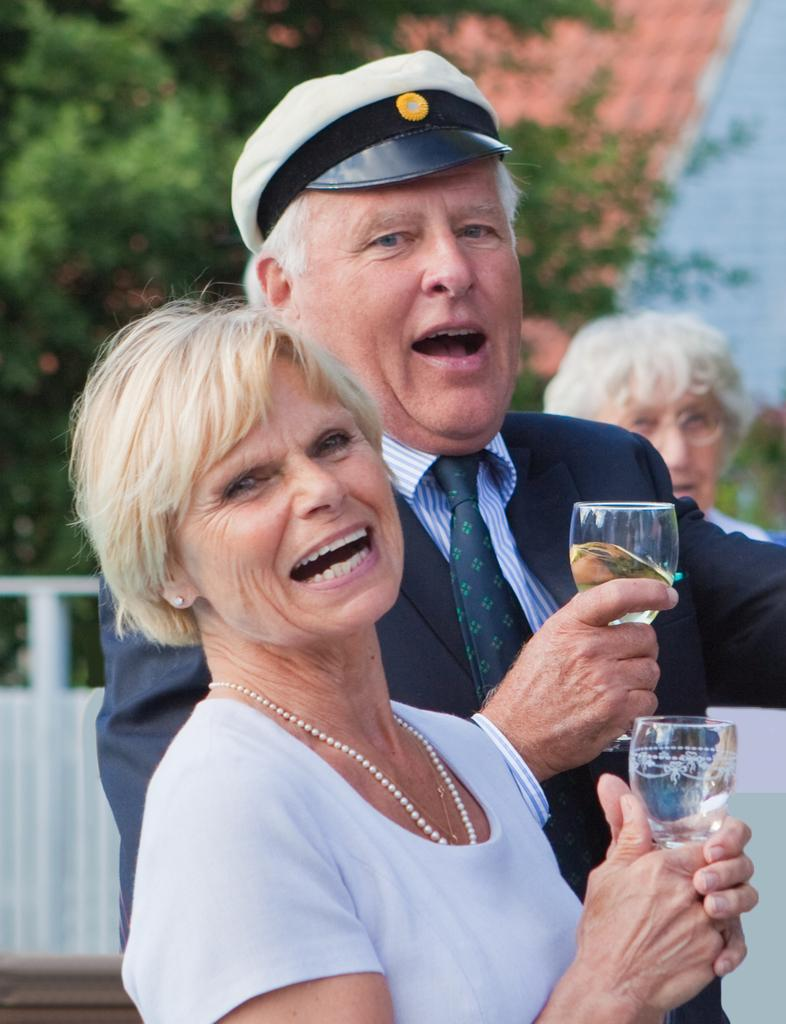Who is present in the image? There is a man and a woman in the image. What are the man and the woman holding in their hands? Both the man and the woman are holding glasses in their hands. What is the facial expression of the man and the woman? The man and the woman are smiling. What can be seen in the background of the image? There are trees in the background of the image. Can you describe any other person in the image besides the man and the woman? There is a person in the background wearing spectacles. What type of yoke is being used for breakfast in the image? There is no yoke or breakfast present in the image. 